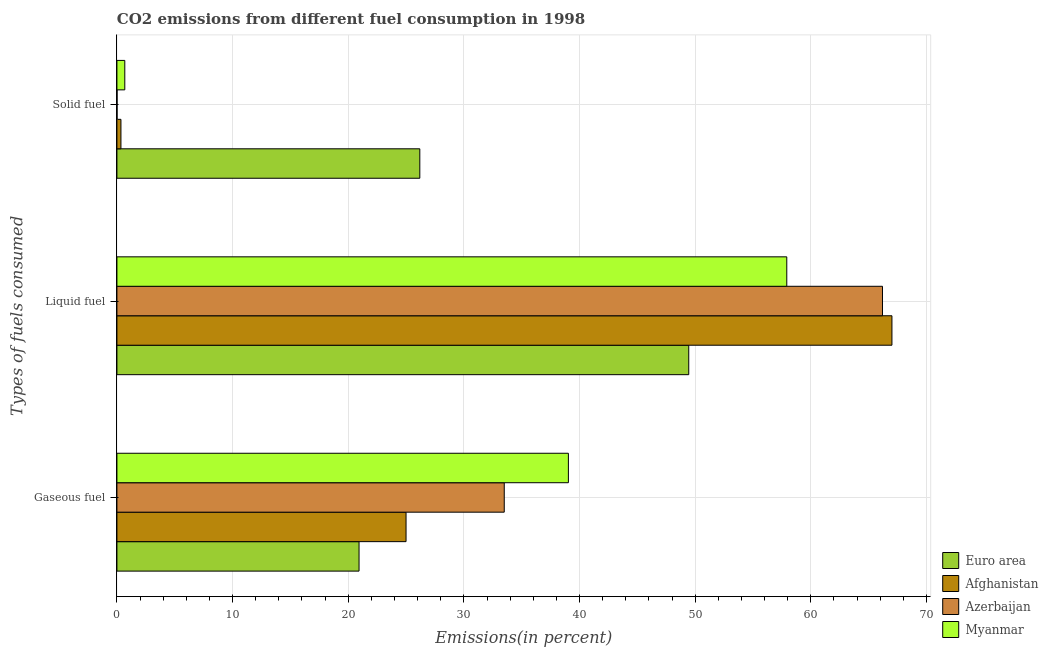How many different coloured bars are there?
Keep it short and to the point. 4. Are the number of bars on each tick of the Y-axis equal?
Keep it short and to the point. Yes. How many bars are there on the 1st tick from the bottom?
Provide a short and direct response. 4. What is the label of the 1st group of bars from the top?
Your answer should be compact. Solid fuel. What is the percentage of solid fuel emission in Azerbaijan?
Offer a very short reply. 0.01. Across all countries, what is the maximum percentage of solid fuel emission?
Your answer should be compact. 26.19. Across all countries, what is the minimum percentage of solid fuel emission?
Your answer should be compact. 0.01. In which country was the percentage of gaseous fuel emission maximum?
Your answer should be very brief. Myanmar. In which country was the percentage of solid fuel emission minimum?
Keep it short and to the point. Azerbaijan. What is the total percentage of gaseous fuel emission in the graph?
Provide a succinct answer. 118.47. What is the difference between the percentage of solid fuel emission in Azerbaijan and that in Euro area?
Offer a terse response. -26.18. What is the difference between the percentage of gaseous fuel emission in Myanmar and the percentage of solid fuel emission in Afghanistan?
Offer a terse response. 38.69. What is the average percentage of liquid fuel emission per country?
Give a very brief answer. 60.14. What is the difference between the percentage of gaseous fuel emission and percentage of liquid fuel emission in Azerbaijan?
Provide a short and direct response. -32.7. What is the ratio of the percentage of solid fuel emission in Azerbaijan to that in Euro area?
Give a very brief answer. 0. Is the difference between the percentage of gaseous fuel emission in Myanmar and Afghanistan greater than the difference between the percentage of liquid fuel emission in Myanmar and Afghanistan?
Offer a very short reply. Yes. What is the difference between the highest and the second highest percentage of liquid fuel emission?
Your answer should be very brief. 0.82. What is the difference between the highest and the lowest percentage of liquid fuel emission?
Provide a succinct answer. 17.57. In how many countries, is the percentage of solid fuel emission greater than the average percentage of solid fuel emission taken over all countries?
Your answer should be compact. 1. Is the sum of the percentage of liquid fuel emission in Azerbaijan and Euro area greater than the maximum percentage of gaseous fuel emission across all countries?
Your answer should be very brief. Yes. What does the 1st bar from the top in Gaseous fuel represents?
Ensure brevity in your answer.  Myanmar. Is it the case that in every country, the sum of the percentage of gaseous fuel emission and percentage of liquid fuel emission is greater than the percentage of solid fuel emission?
Your response must be concise. Yes. Are all the bars in the graph horizontal?
Give a very brief answer. Yes. How many countries are there in the graph?
Your answer should be very brief. 4. Are the values on the major ticks of X-axis written in scientific E-notation?
Your answer should be compact. No. Does the graph contain grids?
Offer a very short reply. Yes. Where does the legend appear in the graph?
Your answer should be compact. Bottom right. How many legend labels are there?
Make the answer very short. 4. What is the title of the graph?
Your answer should be very brief. CO2 emissions from different fuel consumption in 1998. What is the label or title of the X-axis?
Your answer should be very brief. Emissions(in percent). What is the label or title of the Y-axis?
Keep it short and to the point. Types of fuels consumed. What is the Emissions(in percent) of Euro area in Gaseous fuel?
Provide a short and direct response. 20.94. What is the Emissions(in percent) in Afghanistan in Gaseous fuel?
Make the answer very short. 25. What is the Emissions(in percent) in Azerbaijan in Gaseous fuel?
Make the answer very short. 33.49. What is the Emissions(in percent) of Myanmar in Gaseous fuel?
Offer a terse response. 39.04. What is the Emissions(in percent) of Euro area in Liquid fuel?
Offer a very short reply. 49.44. What is the Emissions(in percent) of Afghanistan in Liquid fuel?
Offer a very short reply. 67.01. What is the Emissions(in percent) of Azerbaijan in Liquid fuel?
Your answer should be very brief. 66.2. What is the Emissions(in percent) in Myanmar in Liquid fuel?
Offer a very short reply. 57.92. What is the Emissions(in percent) in Euro area in Solid fuel?
Ensure brevity in your answer.  26.19. What is the Emissions(in percent) in Afghanistan in Solid fuel?
Keep it short and to the point. 0.35. What is the Emissions(in percent) of Azerbaijan in Solid fuel?
Offer a very short reply. 0.01. What is the Emissions(in percent) in Myanmar in Solid fuel?
Provide a short and direct response. 0.68. Across all Types of fuels consumed, what is the maximum Emissions(in percent) of Euro area?
Your answer should be very brief. 49.44. Across all Types of fuels consumed, what is the maximum Emissions(in percent) in Afghanistan?
Give a very brief answer. 67.01. Across all Types of fuels consumed, what is the maximum Emissions(in percent) in Azerbaijan?
Your response must be concise. 66.2. Across all Types of fuels consumed, what is the maximum Emissions(in percent) of Myanmar?
Offer a terse response. 57.92. Across all Types of fuels consumed, what is the minimum Emissions(in percent) in Euro area?
Your answer should be compact. 20.94. Across all Types of fuels consumed, what is the minimum Emissions(in percent) of Afghanistan?
Offer a very short reply. 0.35. Across all Types of fuels consumed, what is the minimum Emissions(in percent) of Azerbaijan?
Offer a terse response. 0.01. Across all Types of fuels consumed, what is the minimum Emissions(in percent) of Myanmar?
Provide a succinct answer. 0.68. What is the total Emissions(in percent) in Euro area in the graph?
Provide a succinct answer. 96.57. What is the total Emissions(in percent) of Afghanistan in the graph?
Your answer should be compact. 92.36. What is the total Emissions(in percent) in Azerbaijan in the graph?
Keep it short and to the point. 99.7. What is the total Emissions(in percent) of Myanmar in the graph?
Keep it short and to the point. 97.64. What is the difference between the Emissions(in percent) in Euro area in Gaseous fuel and that in Liquid fuel?
Your answer should be very brief. -28.51. What is the difference between the Emissions(in percent) in Afghanistan in Gaseous fuel and that in Liquid fuel?
Provide a short and direct response. -42.01. What is the difference between the Emissions(in percent) of Azerbaijan in Gaseous fuel and that in Liquid fuel?
Keep it short and to the point. -32.7. What is the difference between the Emissions(in percent) of Myanmar in Gaseous fuel and that in Liquid fuel?
Your answer should be compact. -18.88. What is the difference between the Emissions(in percent) in Euro area in Gaseous fuel and that in Solid fuel?
Give a very brief answer. -5.25. What is the difference between the Emissions(in percent) of Afghanistan in Gaseous fuel and that in Solid fuel?
Your response must be concise. 24.65. What is the difference between the Emissions(in percent) in Azerbaijan in Gaseous fuel and that in Solid fuel?
Your response must be concise. 33.48. What is the difference between the Emissions(in percent) in Myanmar in Gaseous fuel and that in Solid fuel?
Your answer should be compact. 38.36. What is the difference between the Emissions(in percent) of Euro area in Liquid fuel and that in Solid fuel?
Provide a short and direct response. 23.25. What is the difference between the Emissions(in percent) in Afghanistan in Liquid fuel and that in Solid fuel?
Keep it short and to the point. 66.67. What is the difference between the Emissions(in percent) in Azerbaijan in Liquid fuel and that in Solid fuel?
Provide a succinct answer. 66.18. What is the difference between the Emissions(in percent) in Myanmar in Liquid fuel and that in Solid fuel?
Offer a terse response. 57.24. What is the difference between the Emissions(in percent) in Euro area in Gaseous fuel and the Emissions(in percent) in Afghanistan in Liquid fuel?
Make the answer very short. -46.08. What is the difference between the Emissions(in percent) in Euro area in Gaseous fuel and the Emissions(in percent) in Azerbaijan in Liquid fuel?
Ensure brevity in your answer.  -45.26. What is the difference between the Emissions(in percent) of Euro area in Gaseous fuel and the Emissions(in percent) of Myanmar in Liquid fuel?
Give a very brief answer. -36.98. What is the difference between the Emissions(in percent) of Afghanistan in Gaseous fuel and the Emissions(in percent) of Azerbaijan in Liquid fuel?
Make the answer very short. -41.2. What is the difference between the Emissions(in percent) of Afghanistan in Gaseous fuel and the Emissions(in percent) of Myanmar in Liquid fuel?
Provide a short and direct response. -32.92. What is the difference between the Emissions(in percent) of Azerbaijan in Gaseous fuel and the Emissions(in percent) of Myanmar in Liquid fuel?
Give a very brief answer. -24.43. What is the difference between the Emissions(in percent) of Euro area in Gaseous fuel and the Emissions(in percent) of Afghanistan in Solid fuel?
Provide a short and direct response. 20.59. What is the difference between the Emissions(in percent) in Euro area in Gaseous fuel and the Emissions(in percent) in Azerbaijan in Solid fuel?
Provide a short and direct response. 20.92. What is the difference between the Emissions(in percent) of Euro area in Gaseous fuel and the Emissions(in percent) of Myanmar in Solid fuel?
Give a very brief answer. 20.26. What is the difference between the Emissions(in percent) in Afghanistan in Gaseous fuel and the Emissions(in percent) in Azerbaijan in Solid fuel?
Your answer should be compact. 24.99. What is the difference between the Emissions(in percent) in Afghanistan in Gaseous fuel and the Emissions(in percent) in Myanmar in Solid fuel?
Offer a very short reply. 24.32. What is the difference between the Emissions(in percent) in Azerbaijan in Gaseous fuel and the Emissions(in percent) in Myanmar in Solid fuel?
Give a very brief answer. 32.81. What is the difference between the Emissions(in percent) of Euro area in Liquid fuel and the Emissions(in percent) of Afghanistan in Solid fuel?
Your response must be concise. 49.1. What is the difference between the Emissions(in percent) of Euro area in Liquid fuel and the Emissions(in percent) of Azerbaijan in Solid fuel?
Give a very brief answer. 49.43. What is the difference between the Emissions(in percent) in Euro area in Liquid fuel and the Emissions(in percent) in Myanmar in Solid fuel?
Your answer should be compact. 48.76. What is the difference between the Emissions(in percent) in Afghanistan in Liquid fuel and the Emissions(in percent) in Azerbaijan in Solid fuel?
Ensure brevity in your answer.  67. What is the difference between the Emissions(in percent) of Afghanistan in Liquid fuel and the Emissions(in percent) of Myanmar in Solid fuel?
Your answer should be compact. 66.33. What is the difference between the Emissions(in percent) in Azerbaijan in Liquid fuel and the Emissions(in percent) in Myanmar in Solid fuel?
Offer a terse response. 65.52. What is the average Emissions(in percent) in Euro area per Types of fuels consumed?
Your answer should be compact. 32.19. What is the average Emissions(in percent) in Afghanistan per Types of fuels consumed?
Make the answer very short. 30.79. What is the average Emissions(in percent) of Azerbaijan per Types of fuels consumed?
Your answer should be very brief. 33.23. What is the average Emissions(in percent) in Myanmar per Types of fuels consumed?
Keep it short and to the point. 32.55. What is the difference between the Emissions(in percent) of Euro area and Emissions(in percent) of Afghanistan in Gaseous fuel?
Offer a terse response. -4.06. What is the difference between the Emissions(in percent) of Euro area and Emissions(in percent) of Azerbaijan in Gaseous fuel?
Offer a terse response. -12.56. What is the difference between the Emissions(in percent) in Euro area and Emissions(in percent) in Myanmar in Gaseous fuel?
Your answer should be very brief. -18.1. What is the difference between the Emissions(in percent) in Afghanistan and Emissions(in percent) in Azerbaijan in Gaseous fuel?
Make the answer very short. -8.49. What is the difference between the Emissions(in percent) in Afghanistan and Emissions(in percent) in Myanmar in Gaseous fuel?
Your response must be concise. -14.04. What is the difference between the Emissions(in percent) of Azerbaijan and Emissions(in percent) of Myanmar in Gaseous fuel?
Offer a terse response. -5.55. What is the difference between the Emissions(in percent) of Euro area and Emissions(in percent) of Afghanistan in Liquid fuel?
Your answer should be very brief. -17.57. What is the difference between the Emissions(in percent) of Euro area and Emissions(in percent) of Azerbaijan in Liquid fuel?
Provide a short and direct response. -16.75. What is the difference between the Emissions(in percent) of Euro area and Emissions(in percent) of Myanmar in Liquid fuel?
Make the answer very short. -8.48. What is the difference between the Emissions(in percent) of Afghanistan and Emissions(in percent) of Azerbaijan in Liquid fuel?
Give a very brief answer. 0.82. What is the difference between the Emissions(in percent) of Afghanistan and Emissions(in percent) of Myanmar in Liquid fuel?
Offer a terse response. 9.09. What is the difference between the Emissions(in percent) in Azerbaijan and Emissions(in percent) in Myanmar in Liquid fuel?
Keep it short and to the point. 8.27. What is the difference between the Emissions(in percent) in Euro area and Emissions(in percent) in Afghanistan in Solid fuel?
Make the answer very short. 25.84. What is the difference between the Emissions(in percent) of Euro area and Emissions(in percent) of Azerbaijan in Solid fuel?
Your response must be concise. 26.18. What is the difference between the Emissions(in percent) in Euro area and Emissions(in percent) in Myanmar in Solid fuel?
Make the answer very short. 25.51. What is the difference between the Emissions(in percent) of Afghanistan and Emissions(in percent) of Azerbaijan in Solid fuel?
Give a very brief answer. 0.34. What is the difference between the Emissions(in percent) in Afghanistan and Emissions(in percent) in Myanmar in Solid fuel?
Ensure brevity in your answer.  -0.33. What is the difference between the Emissions(in percent) of Azerbaijan and Emissions(in percent) of Myanmar in Solid fuel?
Keep it short and to the point. -0.67. What is the ratio of the Emissions(in percent) of Euro area in Gaseous fuel to that in Liquid fuel?
Provide a succinct answer. 0.42. What is the ratio of the Emissions(in percent) in Afghanistan in Gaseous fuel to that in Liquid fuel?
Offer a terse response. 0.37. What is the ratio of the Emissions(in percent) in Azerbaijan in Gaseous fuel to that in Liquid fuel?
Ensure brevity in your answer.  0.51. What is the ratio of the Emissions(in percent) in Myanmar in Gaseous fuel to that in Liquid fuel?
Ensure brevity in your answer.  0.67. What is the ratio of the Emissions(in percent) in Euro area in Gaseous fuel to that in Solid fuel?
Offer a very short reply. 0.8. What is the ratio of the Emissions(in percent) in Afghanistan in Gaseous fuel to that in Solid fuel?
Offer a terse response. 72. What is the ratio of the Emissions(in percent) in Azerbaijan in Gaseous fuel to that in Solid fuel?
Your answer should be compact. 2893. What is the ratio of the Emissions(in percent) of Myanmar in Gaseous fuel to that in Solid fuel?
Keep it short and to the point. 57.33. What is the ratio of the Emissions(in percent) in Euro area in Liquid fuel to that in Solid fuel?
Provide a succinct answer. 1.89. What is the ratio of the Emissions(in percent) of Afghanistan in Liquid fuel to that in Solid fuel?
Your answer should be compact. 193. What is the ratio of the Emissions(in percent) in Azerbaijan in Liquid fuel to that in Solid fuel?
Offer a terse response. 5718. What is the ratio of the Emissions(in percent) of Myanmar in Liquid fuel to that in Solid fuel?
Provide a short and direct response. 85.07. What is the difference between the highest and the second highest Emissions(in percent) in Euro area?
Provide a short and direct response. 23.25. What is the difference between the highest and the second highest Emissions(in percent) of Afghanistan?
Your answer should be very brief. 42.01. What is the difference between the highest and the second highest Emissions(in percent) of Azerbaijan?
Offer a terse response. 32.7. What is the difference between the highest and the second highest Emissions(in percent) in Myanmar?
Keep it short and to the point. 18.88. What is the difference between the highest and the lowest Emissions(in percent) of Euro area?
Provide a short and direct response. 28.51. What is the difference between the highest and the lowest Emissions(in percent) of Afghanistan?
Provide a short and direct response. 66.67. What is the difference between the highest and the lowest Emissions(in percent) of Azerbaijan?
Keep it short and to the point. 66.18. What is the difference between the highest and the lowest Emissions(in percent) in Myanmar?
Provide a short and direct response. 57.24. 